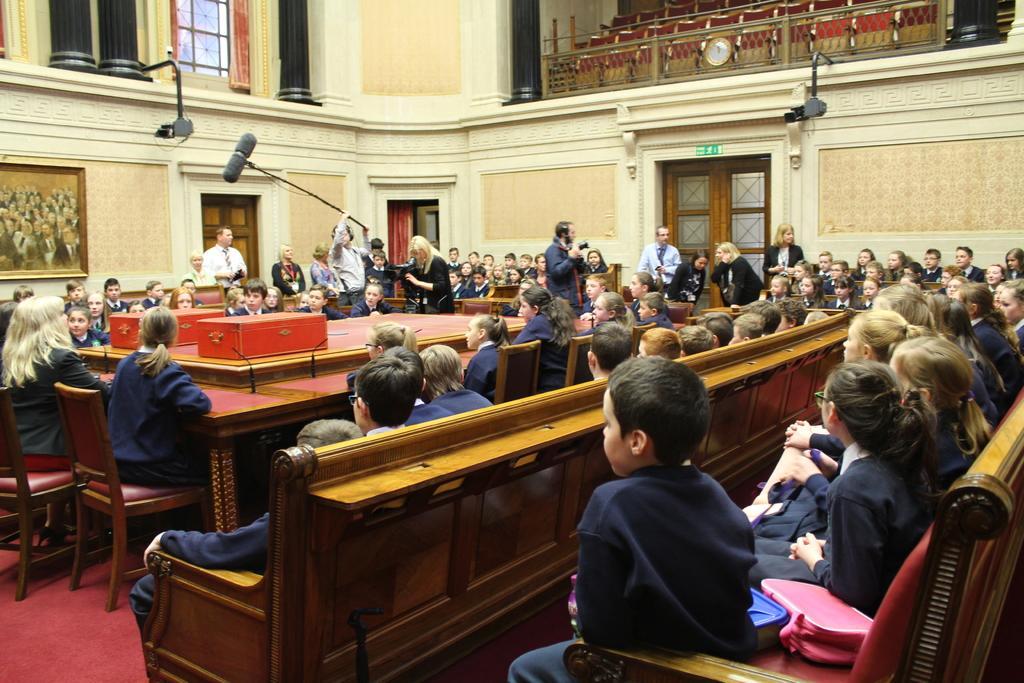How would you summarize this image in a sentence or two? This is the picture of a room. In this image there are group of people sitting and there are group of people standing and there is a man standing and holding the object and there are boxes and microphones on the table. At the back there are doors and pillars and there is a frame and clock and there are objects on the wall. At the bottom there is a mat on the floor. 